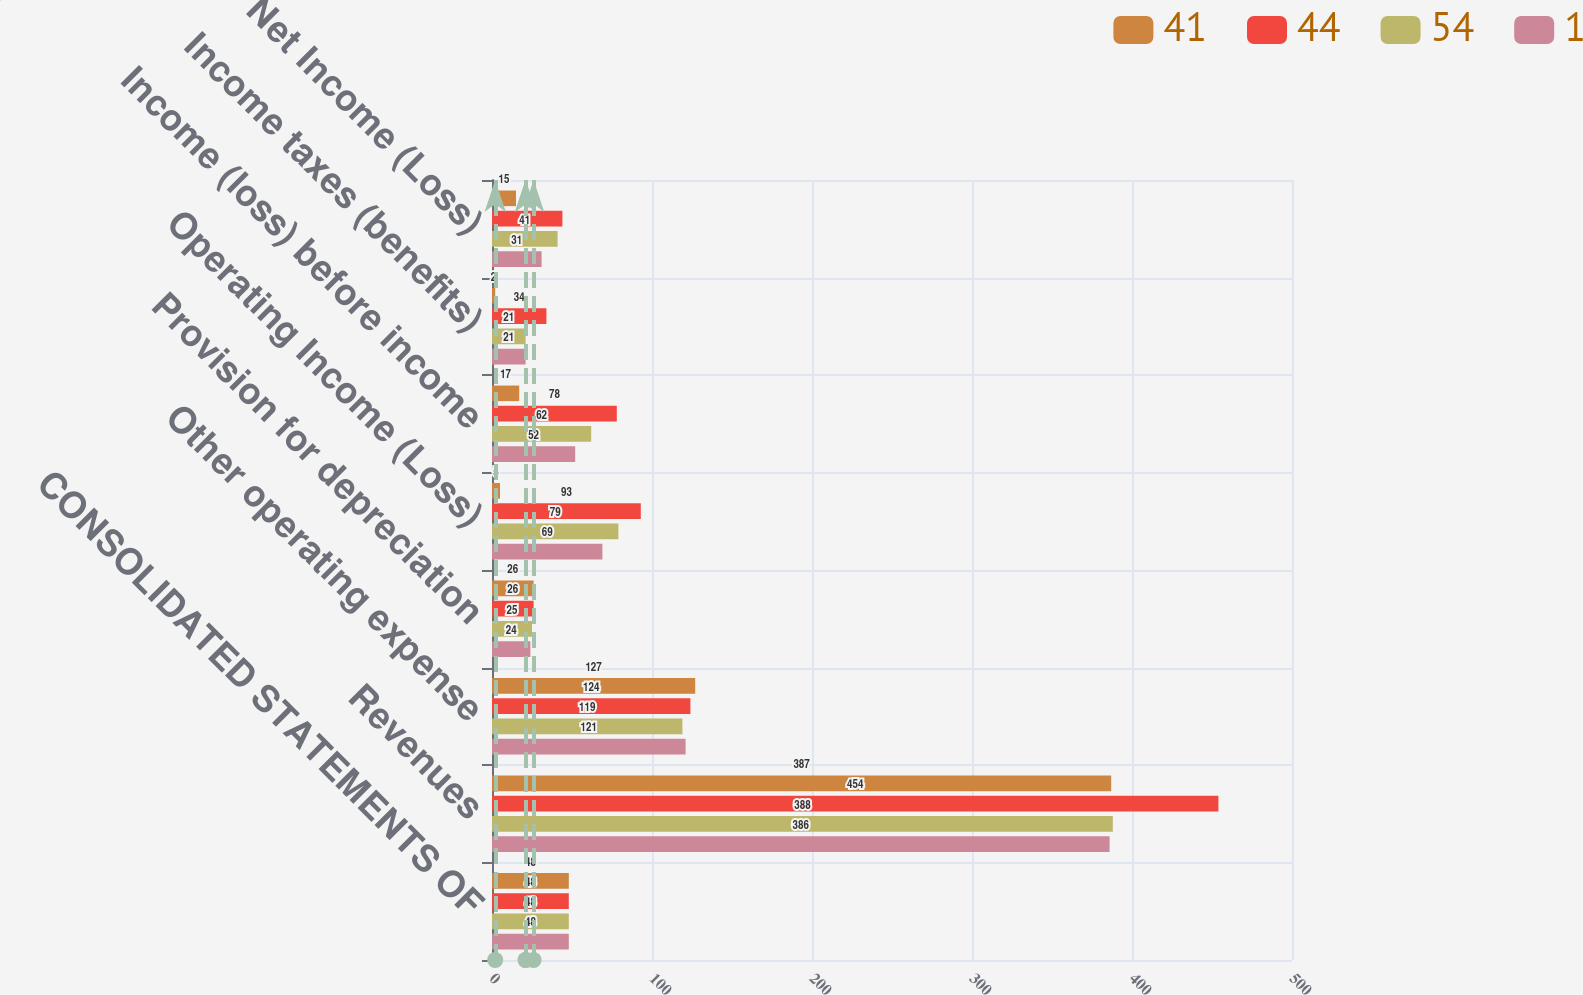Convert chart to OTSL. <chart><loc_0><loc_0><loc_500><loc_500><stacked_bar_chart><ecel><fcel>CONSOLIDATED STATEMENTS OF<fcel>Revenues<fcel>Other operating expense<fcel>Provision for depreciation<fcel>Operating Income (Loss)<fcel>Income (loss) before income<fcel>Income taxes (benefits)<fcel>Net Income (Loss)<nl><fcel>41<fcel>48<fcel>387<fcel>127<fcel>26<fcel>5<fcel>17<fcel>2<fcel>15<nl><fcel>44<fcel>48<fcel>454<fcel>124<fcel>26<fcel>93<fcel>78<fcel>34<fcel>44<nl><fcel>54<fcel>48<fcel>388<fcel>119<fcel>25<fcel>79<fcel>62<fcel>21<fcel>41<nl><fcel>1<fcel>48<fcel>386<fcel>121<fcel>24<fcel>69<fcel>52<fcel>21<fcel>31<nl></chart> 